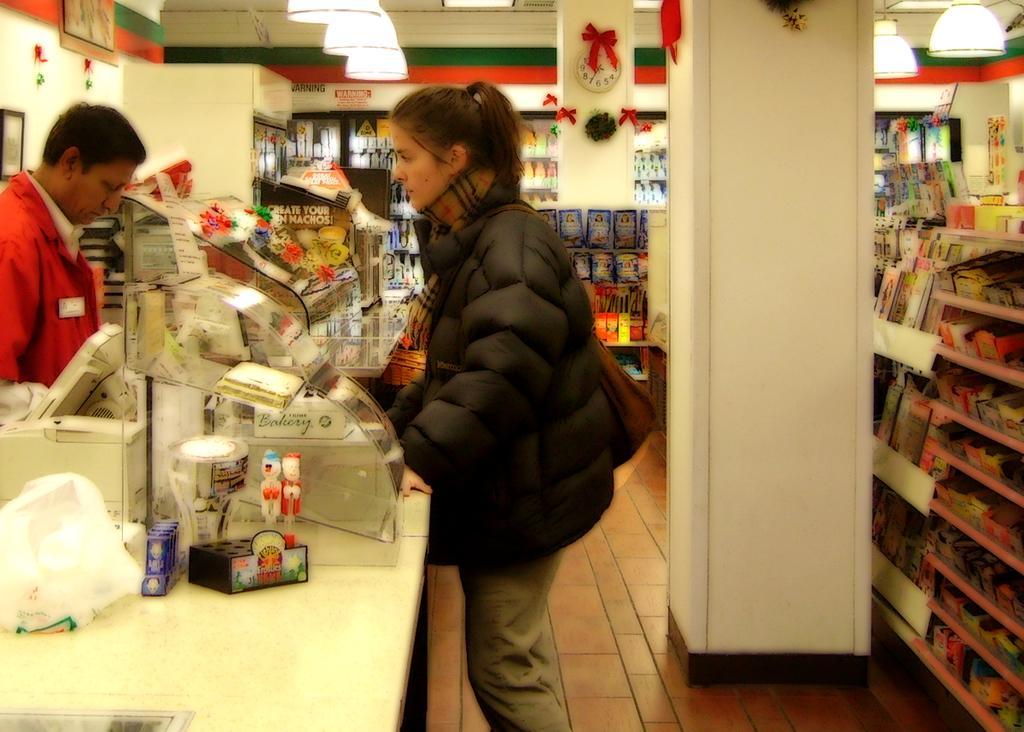In one or two sentences, can you explain what this image depicts? In this picture we can see the lights, pillars, clock, frames, tables, machine, plastic cover, bag, jackets, two people standing on the floor and in the background we can see some objects in racks. 